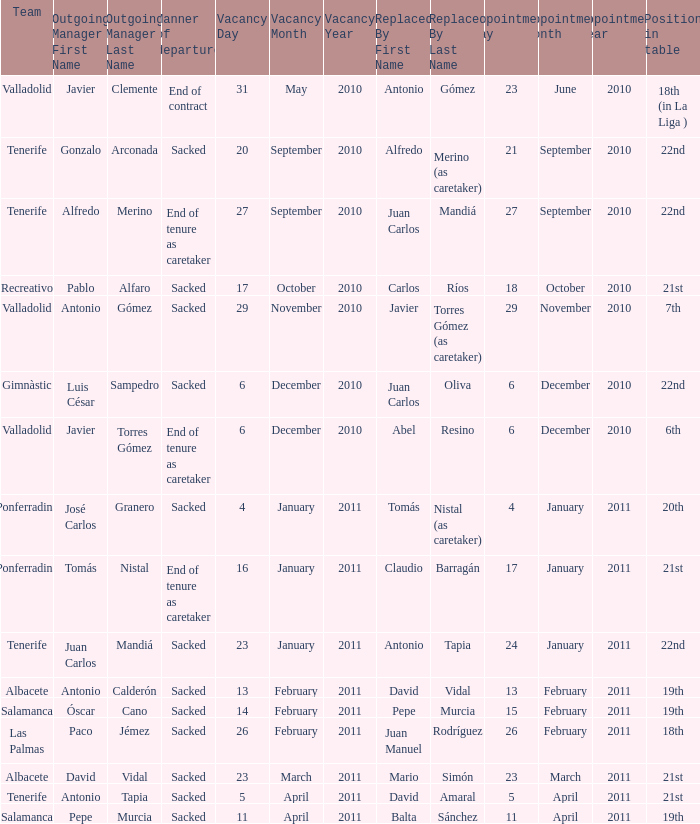What is the position for outgoing manager alfredo merino 22nd. 